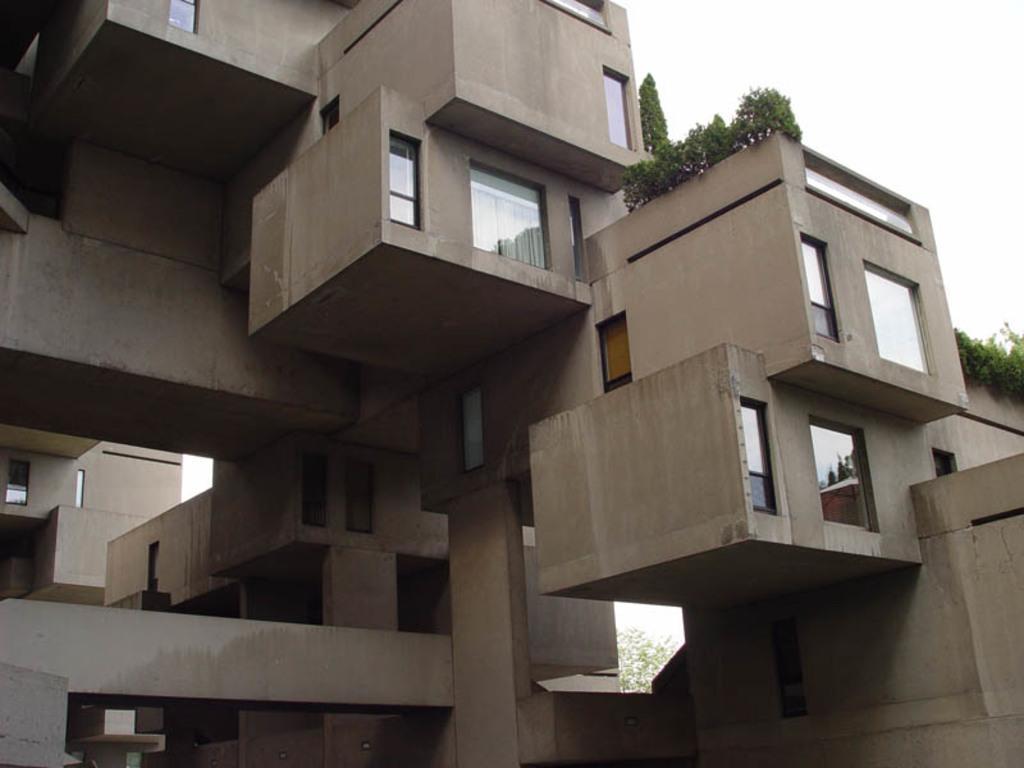Please provide a concise description of this image. In this image we can see a building,we can see a house plant, building having a window. 